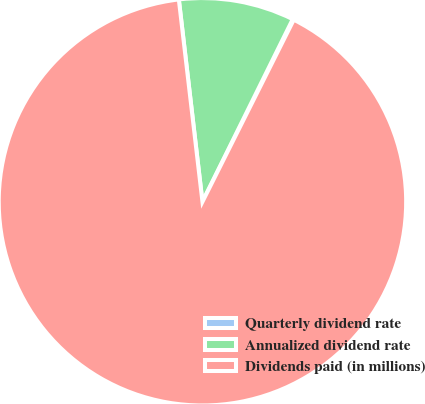<chart> <loc_0><loc_0><loc_500><loc_500><pie_chart><fcel>Quarterly dividend rate<fcel>Annualized dividend rate<fcel>Dividends paid (in millions)<nl><fcel>0.09%<fcel>9.16%<fcel>90.76%<nl></chart> 